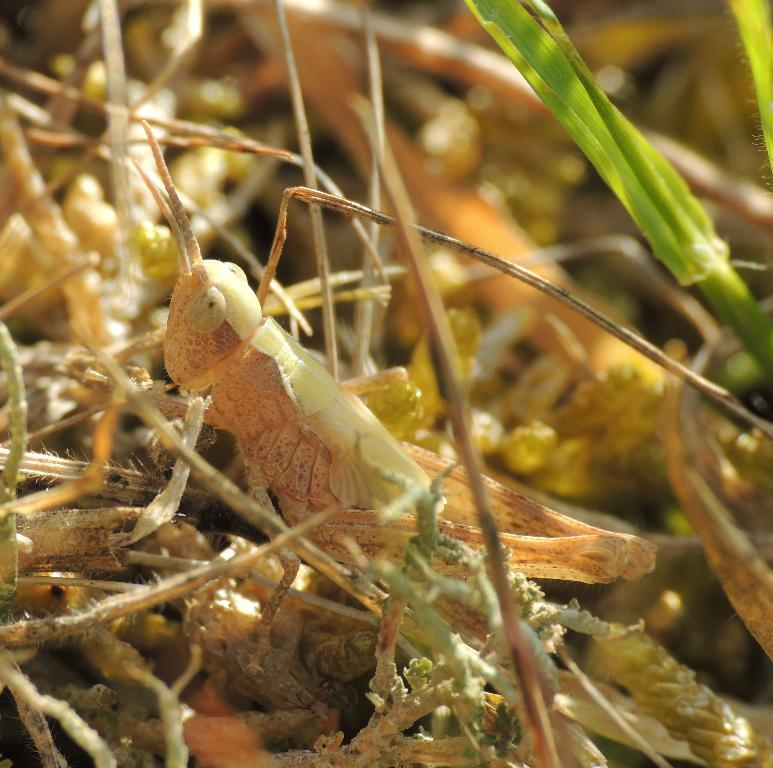What type of creature is present in the image? There is an insect in the image. Can you describe the insect's location in the image? The insect is between twigs. What type of paste is being used by the insect in the image? There is no paste present in the image, and the insect is not using any paste. 